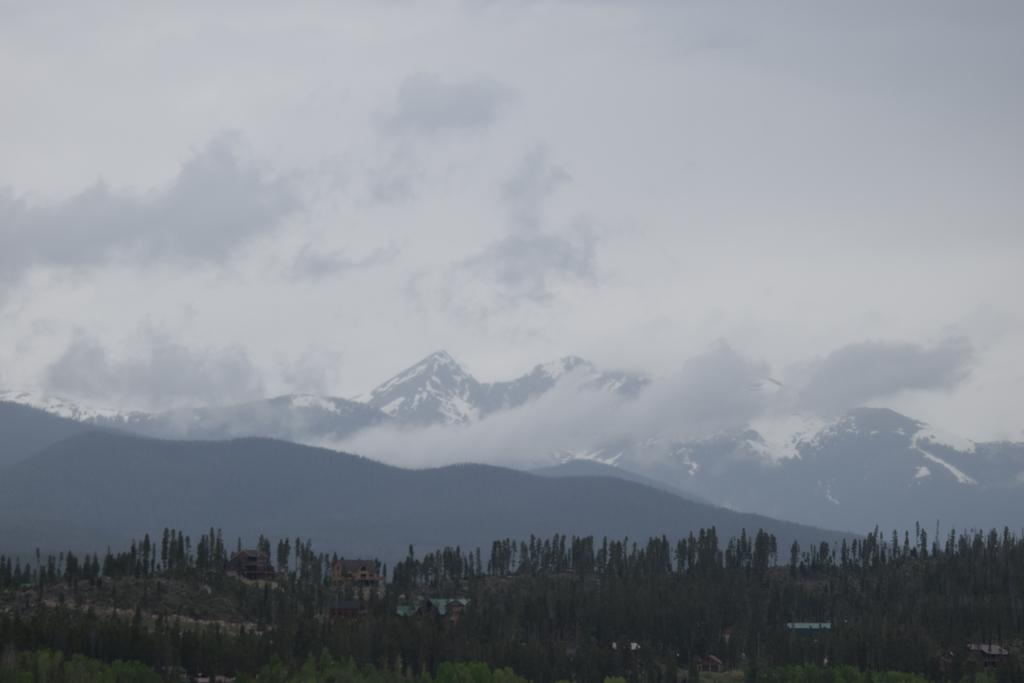What type of natural environment is depicted in the image? The image features many trees, hills, and mountains, indicating a natural landscape. Can you describe the terrain in the image? The image shows hills and mountains, suggesting a hilly or mountainous terrain. What is visible in the sky in the image? The sky is visible in the image, and clouds are present. How many types of landforms can be seen in the image? Three types of landforms can be seen in the image: trees, hills, and mountains. What color is the cherry that is being used as a pen in the image? There is no cherry or pen present in the image; it features a natural landscape with trees, hills, and mountains. 